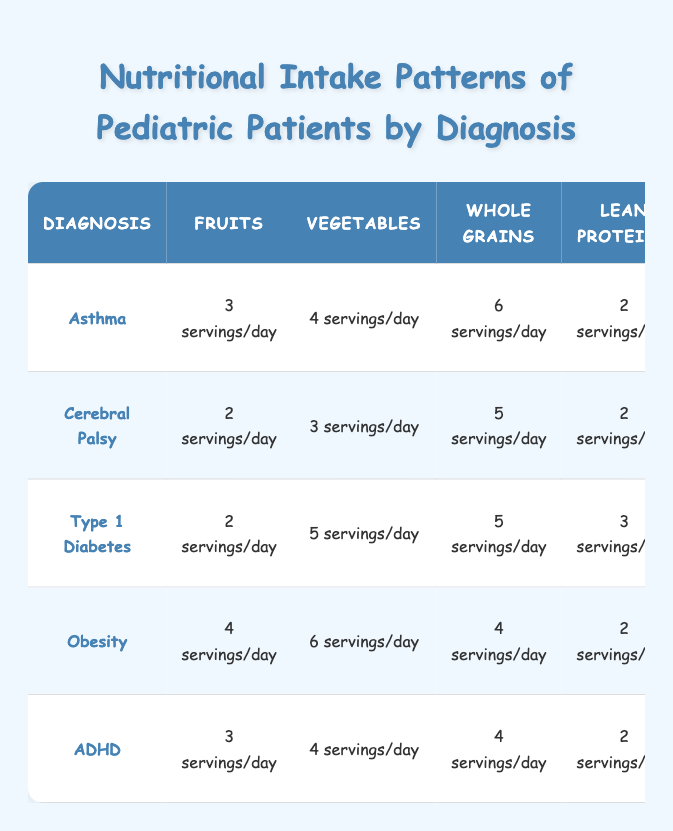What is the recommended daily intake of fruits for patients with Type 1 Diabetes? According to the table, for Type 1 Diabetes, the recommended intake of fruits is 2 servings per day.
Answer: 2 servings/day Which diagnosis has the highest daily servings of vegetables? The diagnosis with the highest daily servings of vegetables is Obesity, with 6 servings per day, as seen in the vegetable column of the table.
Answer: Obesity Is the recommendation for added sugars the same for Asthma and ADHD? No, the recommendation for added sugars is not the same. Asthma allows "<10% of total calories" while ADHD also allows "<10% of total calories", making this a true statement.
Answer: Yes What is the difference in the recommended servings of whole grains between Cerebral Palsy and Type 1 Diabetes? Cerebral Palsy has 5 servings of whole grains while Type 1 Diabetes has 5 servings as well. Therefore, the difference is 0 servings.
Answer: 0 servings What is the average daily intake of dairy across all diagnoses listed? The total dairy intake across all diagnoses is 2 + 2 + 2 + 1 + 2 = 9 servings. There are 5 diagnoses, so the average is 9/5 = 1.8 servings/day.
Answer: 1.8 servings/day For which diagnosis is the recommendation for saturated fats the lowest? Looking at the saturated fats recommendations for each diagnosis, Obesity is the lowest, with "<5% of total calories".
Answer: Obesity Combine the servings of fruits and vegetables recommended for patients with Asthma. The total servings of fruits and vegetables for Asthma is 3 servings (fruits) + 4 servings (vegetables) = 7 servings/day.
Answer: 7 servings/day Which diagnosis requires the highest amount of lean proteins and what is that amount? Type 1 Diabetes requires the highest amount of lean proteins, at 3 servings per day, as indicated in the lean proteins column of the table.
Answer: Type 1 Diabetes, 3 servings/day 